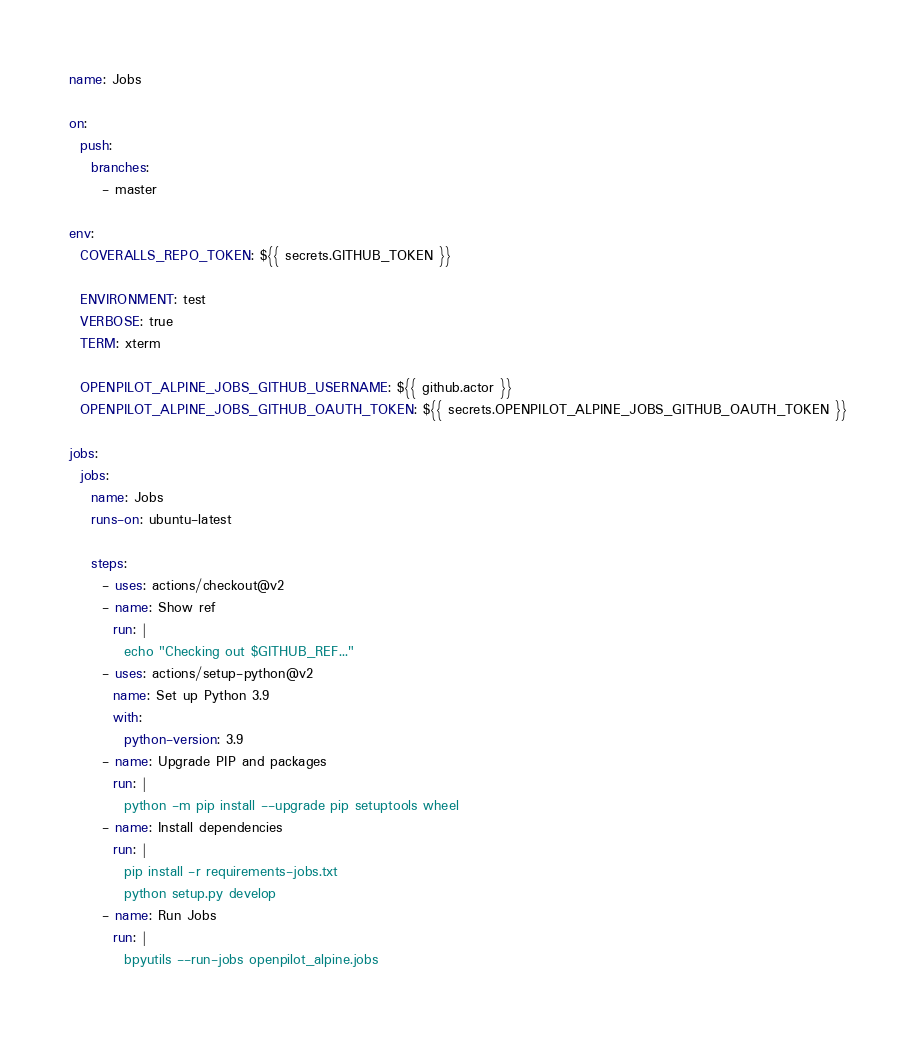<code> <loc_0><loc_0><loc_500><loc_500><_YAML_>name: Jobs

on:
  push:
    branches:
      - master

env:
  COVERALLS_REPO_TOKEN: ${{ secrets.GITHUB_TOKEN }}

  ENVIRONMENT: test
  VERBOSE: true
  TERM: xterm

  OPENPILOT_ALPINE_JOBS_GITHUB_USERNAME: ${{ github.actor }}
  OPENPILOT_ALPINE_JOBS_GITHUB_OAUTH_TOKEN: ${{ secrets.OPENPILOT_ALPINE_JOBS_GITHUB_OAUTH_TOKEN }}

jobs:
  jobs:
    name: Jobs
    runs-on: ubuntu-latest
    
    steps:
      - uses: actions/checkout@v2
      - name: Show ref
        run: |
          echo "Checking out $GITHUB_REF..."
      - uses: actions/setup-python@v2
        name: Set up Python 3.9
        with:
          python-version: 3.9
      - name: Upgrade PIP and packages
        run: |
          python -m pip install --upgrade pip setuptools wheel
      - name: Install dependencies
        run: |
          pip install -r requirements-jobs.txt
          python setup.py develop
      - name: Run Jobs
        run: |
          bpyutils --run-jobs openpilot_alpine.jobs</code> 